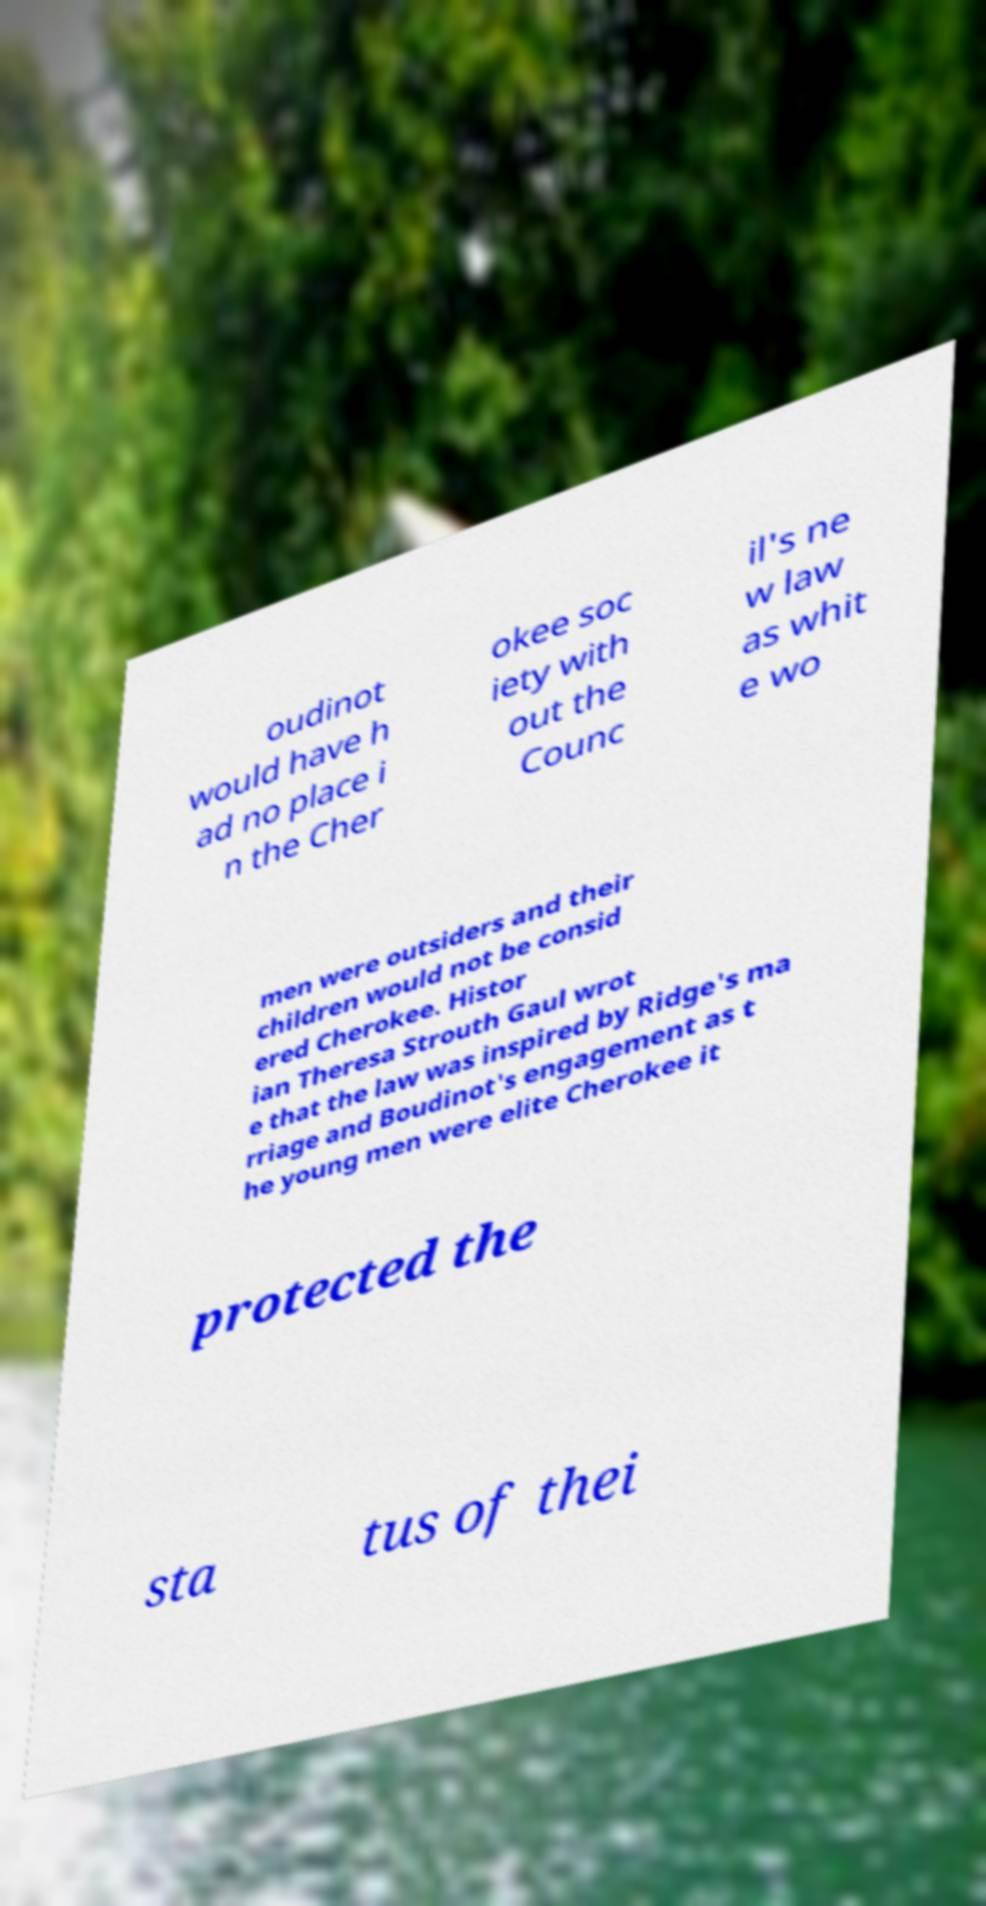Please identify and transcribe the text found in this image. oudinot would have h ad no place i n the Cher okee soc iety with out the Counc il's ne w law as whit e wo men were outsiders and their children would not be consid ered Cherokee. Histor ian Theresa Strouth Gaul wrot e that the law was inspired by Ridge's ma rriage and Boudinot's engagement as t he young men were elite Cherokee it protected the sta tus of thei 